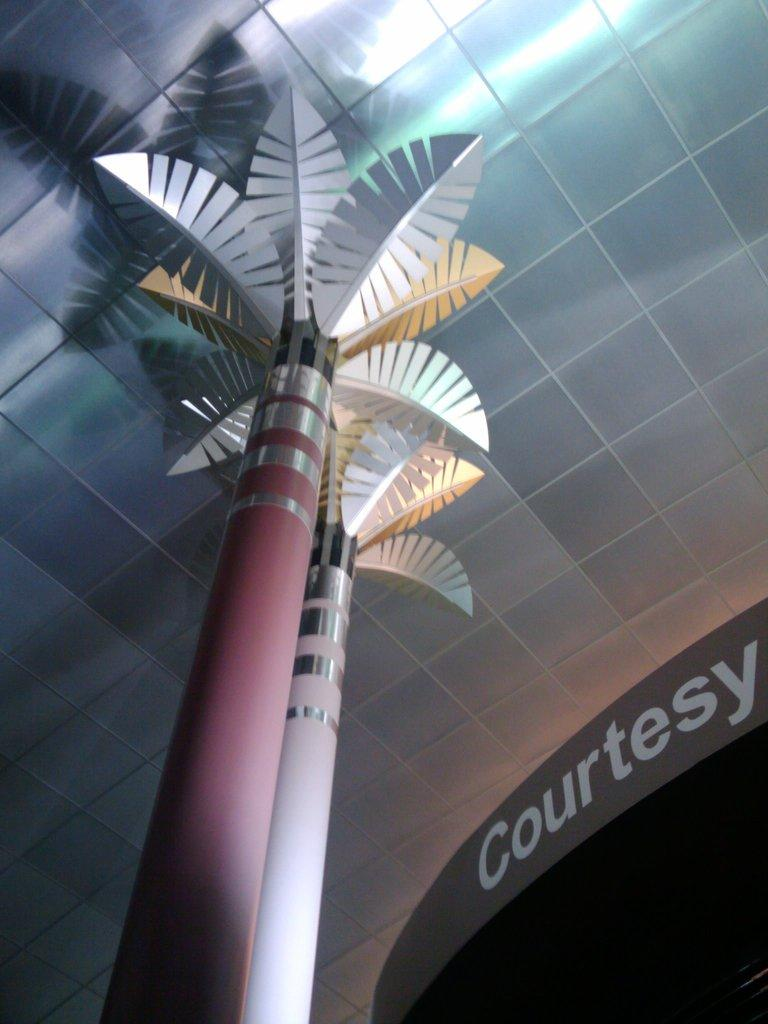What type of tree is in the image? There is an artificial tree in the image. How is the artificial tree supported? The artificial tree is on a pole. What can be seen on the wall in the image? There is text on a wall in the image. Where is the artificial tree located in relation to the wall with text? The artificial tree is in front of the wall with text. How many cushions are on the artificial tree in the image? There are no cushions present on the artificial tree in the image. What type of bomb can be seen near the wall with text? There is no bomb present near the wall with text in the image. 